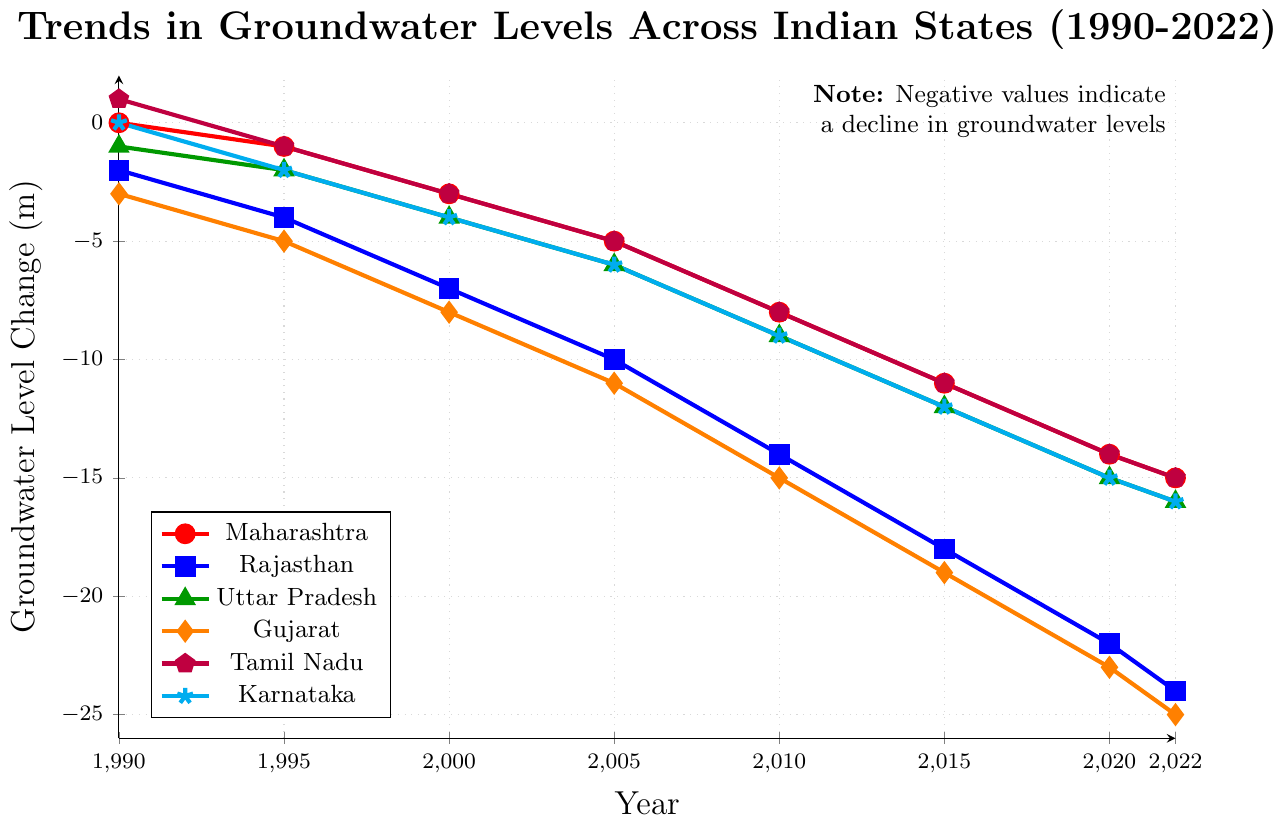What is the general trend of groundwater levels in Maharashtra from 1990 to 2022? The groundwater levels in Maharashtra show a declining trend over the years. Starting from 0 meters in 1990, it gradually decreases to -15 meters in 2022.
Answer: Declining Which state experienced the largest decline in groundwater levels by 2022? To find the state with the largest decline, we compare the groundwater levels in 2022 for all states. Gujarat has the lowest value at -25 meters.
Answer: Gujarat How much did the groundwater level change in Tamil Nadu between 1990 and 2022? The groundwater level in Tamil Nadu was +1 meter in 1990 and -15 meters in 2022. Therefore, the total change is 1 - (-15) which equals 1 + 15 = 16 meters.
Answer: 16 meters Between 2000 and 2020, which state experienced the highest increase in groundwater depletion? Comparing the differences between 2000 and 2020 for each state, Maharashtra: -14 - (-3) = -11, Rajasthan: -22 - (-7) = -15, Uttar Pradesh: -15 - (-4) = -11, Gujarat: -23 - (-8) = -15, Tamil Nadu: -14 - (-3) = -11, Karnataka: -15 - (-4) = -11. Both Rajasthan and Gujarat experienced the highest increase of -15 meters.
Answer: Rajasthan and Gujarat Which state had a positive groundwater level in 1990? By examining the 1990 values, Tamil Nadu had a positive groundwater level at +1 meter.
Answer: Tamil Nadu What is the difference in groundwater level decline between Uttar Pradesh and Karnataka in 2022? For Uttar Pradesh, the level in 2022 is -16 meters; for Karnataka, it is also -16 meters. The difference is -16 - (-16), which equals 0 meters.
Answer: 0 meters What is the average groundwater level in 2022 across all states listed? Summing up the levels in 2022 for all states: -15 (Maharashtra) + (-24) (Rajasthan) + (-16) (Uttar Pradesh) + (-25) (Gujarat) + (-15) (Tamil Nadu) + (-16) (Karnataka) equals -111. There are 6 states, so the average is -111/6 = -18.5 meters.
Answer: -18.5 meters In which year did Rajasthan experience a significant drop in groundwater levels exceeding 4 meters compared to the previous period? Examining the consecutive differences: 1995-1990 = -2, 2000-1995 = -3, 2005-2000 = -3, 2010-2005 = -4, 2015-2010 = -4, 2020-2015 = -4. The largest drop between consecutive periods is 2022-2020 = -2. No significant single-year drop exceeding 4 meters.
Answer: No significant single-year drop Compare the groundwater levels of Gujarat and Tamil Nadu in 2000. Which state had a lower groundwater level? In 2000, Gujarat had -8 meters while Tamil Nadu had -3 meters. Gujarat's level is lower.
Answer: Gujarat 